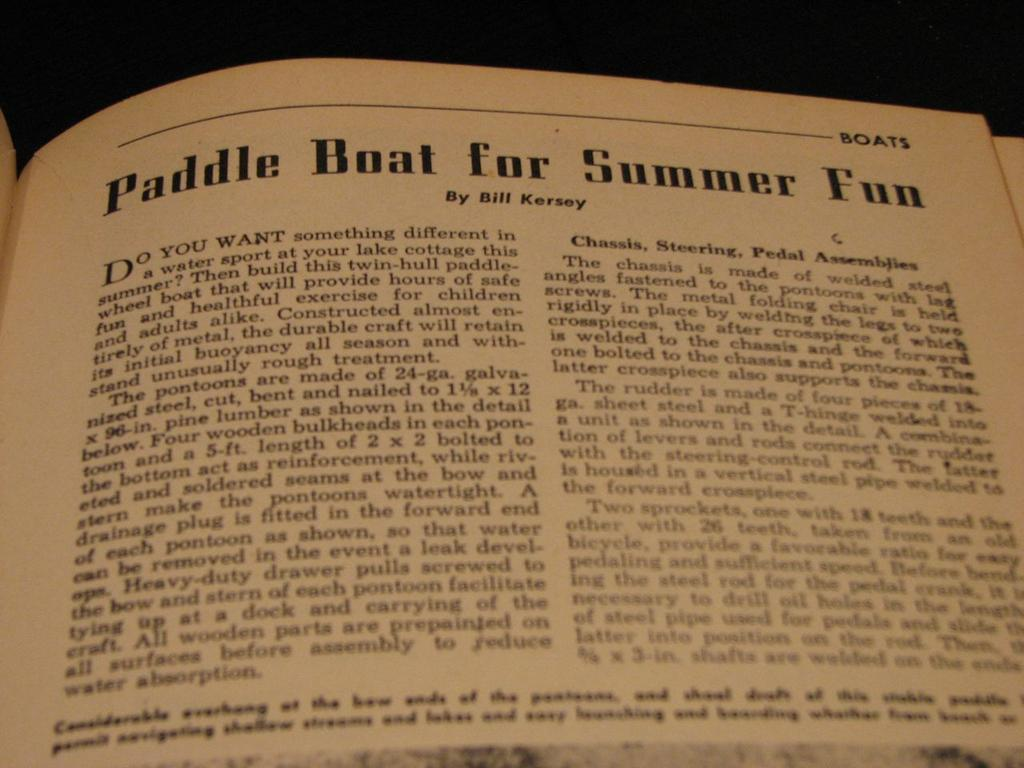<image>
Write a terse but informative summary of the picture. A book is open to a page on paddle boating in the summer. 